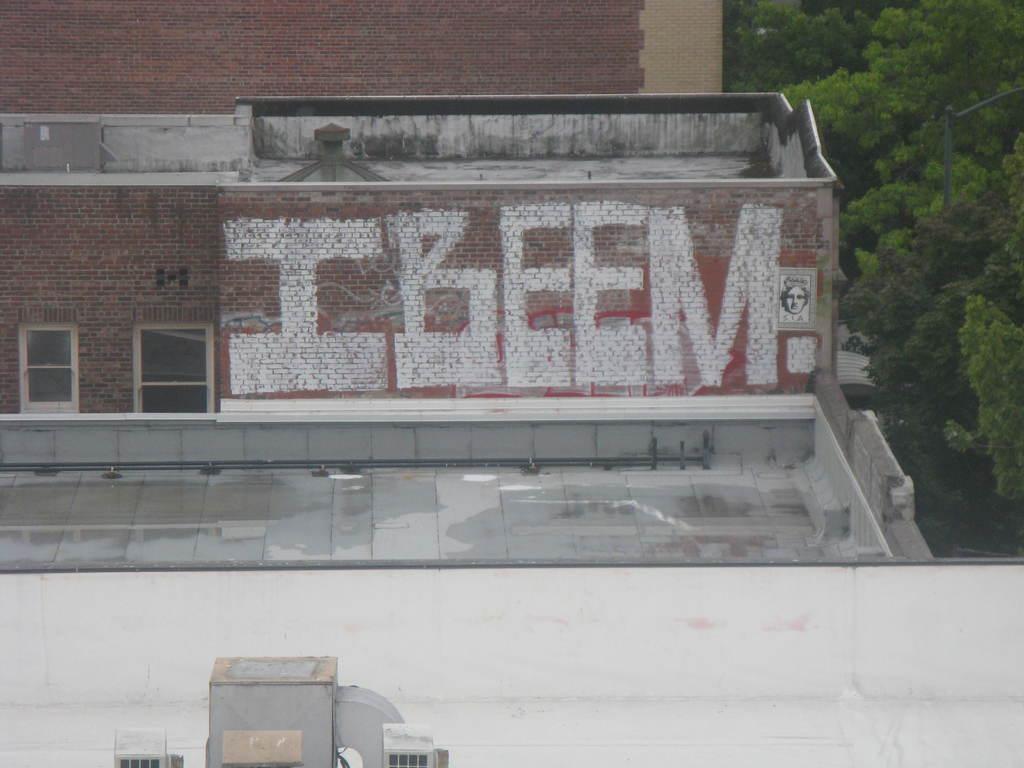Please provide a concise description of this image. In this image we can see windows, buildings, terrace, air conditioners, street light and trees. 